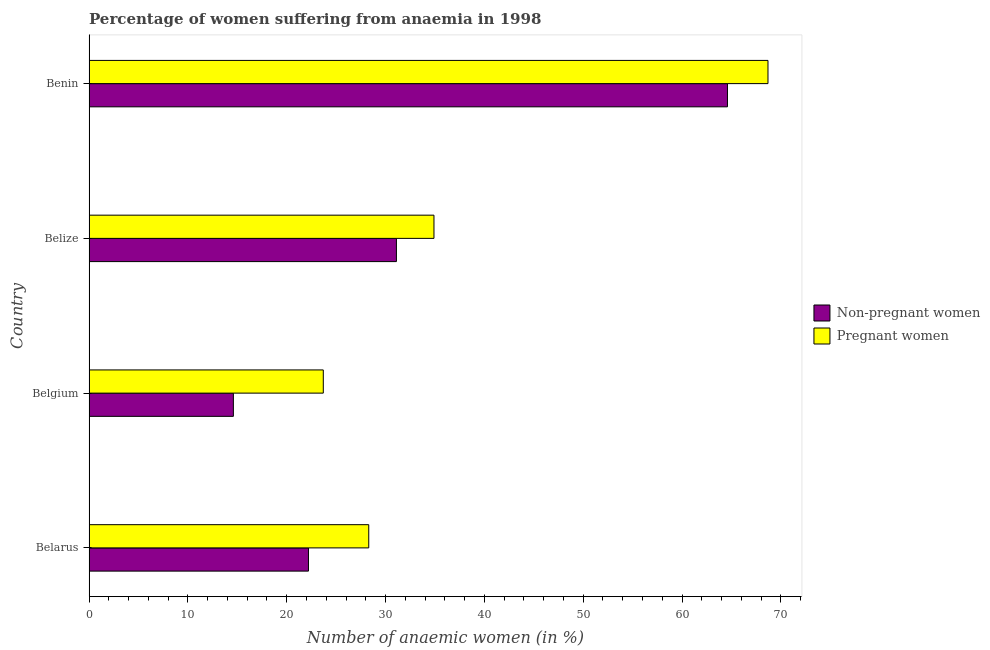How many different coloured bars are there?
Your answer should be compact. 2. Are the number of bars per tick equal to the number of legend labels?
Keep it short and to the point. Yes. Are the number of bars on each tick of the Y-axis equal?
Keep it short and to the point. Yes. What is the label of the 2nd group of bars from the top?
Your answer should be compact. Belize. What is the percentage of pregnant anaemic women in Belize?
Your answer should be very brief. 34.9. Across all countries, what is the maximum percentage of non-pregnant anaemic women?
Your response must be concise. 64.6. Across all countries, what is the minimum percentage of non-pregnant anaemic women?
Your answer should be very brief. 14.6. In which country was the percentage of non-pregnant anaemic women maximum?
Ensure brevity in your answer.  Benin. What is the total percentage of non-pregnant anaemic women in the graph?
Make the answer very short. 132.5. What is the difference between the percentage of non-pregnant anaemic women in Belgium and that in Belize?
Ensure brevity in your answer.  -16.5. What is the difference between the percentage of non-pregnant anaemic women in Belize and the percentage of pregnant anaemic women in Belarus?
Your answer should be compact. 2.8. What is the average percentage of non-pregnant anaemic women per country?
Your answer should be compact. 33.12. What is the ratio of the percentage of non-pregnant anaemic women in Belarus to that in Belgium?
Make the answer very short. 1.52. Is the percentage of non-pregnant anaemic women in Belgium less than that in Belize?
Offer a very short reply. Yes. What is the difference between the highest and the second highest percentage of pregnant anaemic women?
Provide a succinct answer. 33.8. What does the 2nd bar from the top in Belgium represents?
Ensure brevity in your answer.  Non-pregnant women. What does the 1st bar from the bottom in Belize represents?
Offer a very short reply. Non-pregnant women. How many bars are there?
Give a very brief answer. 8. Are the values on the major ticks of X-axis written in scientific E-notation?
Your answer should be compact. No. Does the graph contain any zero values?
Make the answer very short. No. Does the graph contain grids?
Provide a short and direct response. No. Where does the legend appear in the graph?
Keep it short and to the point. Center right. How many legend labels are there?
Give a very brief answer. 2. What is the title of the graph?
Give a very brief answer. Percentage of women suffering from anaemia in 1998. Does "Primary school" appear as one of the legend labels in the graph?
Offer a terse response. No. What is the label or title of the X-axis?
Offer a very short reply. Number of anaemic women (in %). What is the label or title of the Y-axis?
Your answer should be very brief. Country. What is the Number of anaemic women (in %) in Non-pregnant women in Belarus?
Provide a short and direct response. 22.2. What is the Number of anaemic women (in %) in Pregnant women in Belarus?
Ensure brevity in your answer.  28.3. What is the Number of anaemic women (in %) of Pregnant women in Belgium?
Give a very brief answer. 23.7. What is the Number of anaemic women (in %) of Non-pregnant women in Belize?
Make the answer very short. 31.1. What is the Number of anaemic women (in %) of Pregnant women in Belize?
Keep it short and to the point. 34.9. What is the Number of anaemic women (in %) of Non-pregnant women in Benin?
Your answer should be compact. 64.6. What is the Number of anaemic women (in %) in Pregnant women in Benin?
Give a very brief answer. 68.7. Across all countries, what is the maximum Number of anaemic women (in %) in Non-pregnant women?
Your answer should be compact. 64.6. Across all countries, what is the maximum Number of anaemic women (in %) in Pregnant women?
Offer a very short reply. 68.7. Across all countries, what is the minimum Number of anaemic women (in %) in Pregnant women?
Offer a very short reply. 23.7. What is the total Number of anaemic women (in %) in Non-pregnant women in the graph?
Keep it short and to the point. 132.5. What is the total Number of anaemic women (in %) in Pregnant women in the graph?
Your answer should be compact. 155.6. What is the difference between the Number of anaemic women (in %) in Non-pregnant women in Belarus and that in Belgium?
Offer a terse response. 7.6. What is the difference between the Number of anaemic women (in %) in Pregnant women in Belarus and that in Belgium?
Ensure brevity in your answer.  4.6. What is the difference between the Number of anaemic women (in %) in Non-pregnant women in Belarus and that in Belize?
Give a very brief answer. -8.9. What is the difference between the Number of anaemic women (in %) in Non-pregnant women in Belarus and that in Benin?
Provide a succinct answer. -42.4. What is the difference between the Number of anaemic women (in %) of Pregnant women in Belarus and that in Benin?
Keep it short and to the point. -40.4. What is the difference between the Number of anaemic women (in %) of Non-pregnant women in Belgium and that in Belize?
Provide a succinct answer. -16.5. What is the difference between the Number of anaemic women (in %) of Non-pregnant women in Belgium and that in Benin?
Keep it short and to the point. -50. What is the difference between the Number of anaemic women (in %) in Pregnant women in Belgium and that in Benin?
Provide a short and direct response. -45. What is the difference between the Number of anaemic women (in %) of Non-pregnant women in Belize and that in Benin?
Ensure brevity in your answer.  -33.5. What is the difference between the Number of anaemic women (in %) in Pregnant women in Belize and that in Benin?
Make the answer very short. -33.8. What is the difference between the Number of anaemic women (in %) of Non-pregnant women in Belarus and the Number of anaemic women (in %) of Pregnant women in Benin?
Your answer should be very brief. -46.5. What is the difference between the Number of anaemic women (in %) of Non-pregnant women in Belgium and the Number of anaemic women (in %) of Pregnant women in Belize?
Offer a terse response. -20.3. What is the difference between the Number of anaemic women (in %) in Non-pregnant women in Belgium and the Number of anaemic women (in %) in Pregnant women in Benin?
Give a very brief answer. -54.1. What is the difference between the Number of anaemic women (in %) in Non-pregnant women in Belize and the Number of anaemic women (in %) in Pregnant women in Benin?
Give a very brief answer. -37.6. What is the average Number of anaemic women (in %) of Non-pregnant women per country?
Ensure brevity in your answer.  33.12. What is the average Number of anaemic women (in %) of Pregnant women per country?
Offer a terse response. 38.9. What is the difference between the Number of anaemic women (in %) of Non-pregnant women and Number of anaemic women (in %) of Pregnant women in Belgium?
Give a very brief answer. -9.1. What is the difference between the Number of anaemic women (in %) of Non-pregnant women and Number of anaemic women (in %) of Pregnant women in Belize?
Your answer should be compact. -3.8. What is the difference between the Number of anaemic women (in %) in Non-pregnant women and Number of anaemic women (in %) in Pregnant women in Benin?
Your response must be concise. -4.1. What is the ratio of the Number of anaemic women (in %) in Non-pregnant women in Belarus to that in Belgium?
Your response must be concise. 1.52. What is the ratio of the Number of anaemic women (in %) in Pregnant women in Belarus to that in Belgium?
Keep it short and to the point. 1.19. What is the ratio of the Number of anaemic women (in %) of Non-pregnant women in Belarus to that in Belize?
Offer a terse response. 0.71. What is the ratio of the Number of anaemic women (in %) in Pregnant women in Belarus to that in Belize?
Provide a short and direct response. 0.81. What is the ratio of the Number of anaemic women (in %) in Non-pregnant women in Belarus to that in Benin?
Provide a short and direct response. 0.34. What is the ratio of the Number of anaemic women (in %) of Pregnant women in Belarus to that in Benin?
Make the answer very short. 0.41. What is the ratio of the Number of anaemic women (in %) of Non-pregnant women in Belgium to that in Belize?
Provide a short and direct response. 0.47. What is the ratio of the Number of anaemic women (in %) of Pregnant women in Belgium to that in Belize?
Offer a terse response. 0.68. What is the ratio of the Number of anaemic women (in %) in Non-pregnant women in Belgium to that in Benin?
Give a very brief answer. 0.23. What is the ratio of the Number of anaemic women (in %) of Pregnant women in Belgium to that in Benin?
Your answer should be very brief. 0.34. What is the ratio of the Number of anaemic women (in %) in Non-pregnant women in Belize to that in Benin?
Keep it short and to the point. 0.48. What is the ratio of the Number of anaemic women (in %) of Pregnant women in Belize to that in Benin?
Offer a terse response. 0.51. What is the difference between the highest and the second highest Number of anaemic women (in %) in Non-pregnant women?
Your answer should be very brief. 33.5. What is the difference between the highest and the second highest Number of anaemic women (in %) of Pregnant women?
Provide a succinct answer. 33.8. 